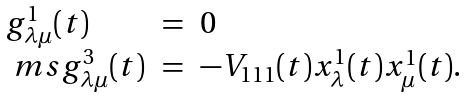Convert formula to latex. <formula><loc_0><loc_0><loc_500><loc_500>\begin{array} { l c l } g ^ { 1 } _ { \lambda \mu } ( t ) & = & 0 \\ { \ m s } g ^ { 3 } _ { \lambda \mu } ( t ) & = & - V _ { 1 1 1 } ( t ) x ^ { 1 } _ { \lambda } ( t ) x ^ { 1 } _ { \mu } ( t ) . \\ \end{array}</formula> 